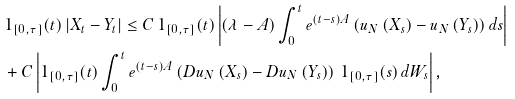<formula> <loc_0><loc_0><loc_500><loc_500>& 1 _ { [ 0 , \tau ] } ( t ) \left | X _ { t } - Y _ { t } \right | \leq C \, 1 _ { [ 0 , \tau ] } ( t ) \left | \left ( \lambda - A \right ) \int _ { 0 } ^ { t } e ^ { \left ( t - s \right ) A } \left ( u _ { N } \left ( X _ { s } \right ) - u _ { N } \left ( Y _ { s } \right ) \right ) d s \right | \\ & + C \left | 1 _ { [ 0 , \tau ] } ( t ) \int _ { 0 } ^ { t } e ^ { \left ( t - s \right ) A } \left ( D u _ { N } \left ( X _ { s } \right ) - D u _ { N } \left ( Y _ { s } \right ) \right ) \, 1 _ { [ 0 , \tau ] } ( s ) \, d W _ { s } \right | ,</formula> 